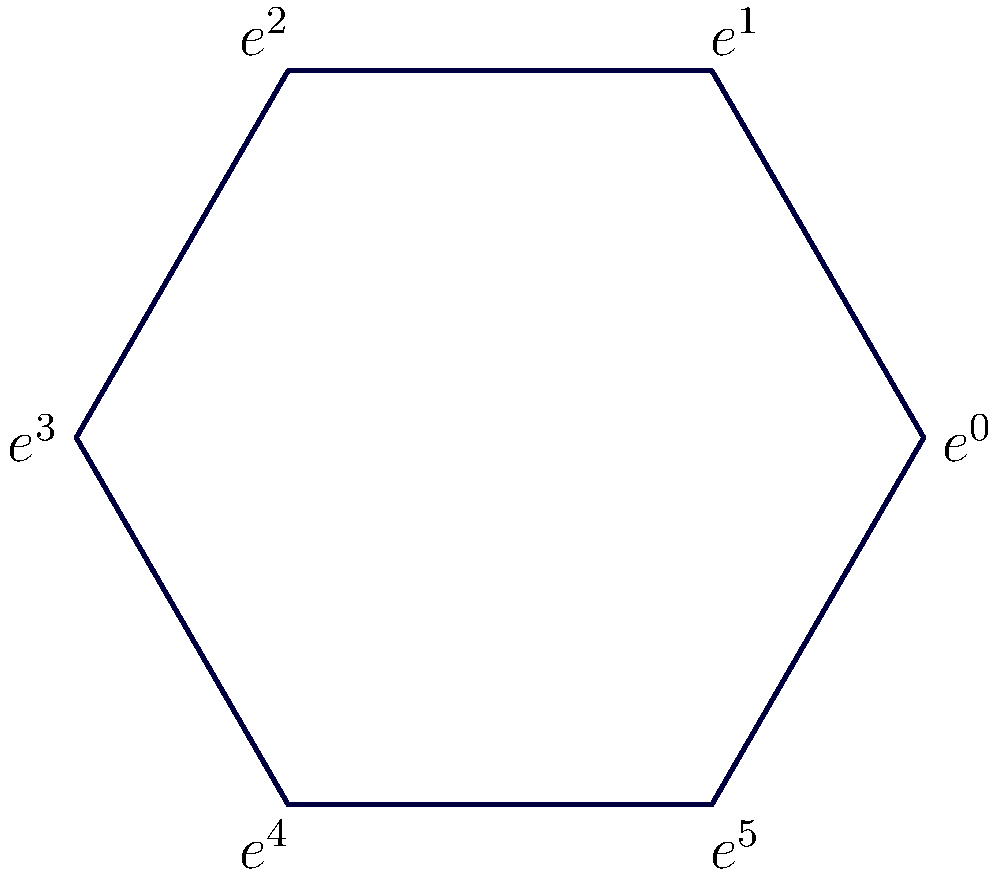Dans le contexte de la théorie des groupes, considérez le diagramme hexagonal représentant le groupe cyclique d'ordre 6. Si $r$ représente la rotation de 60° dans le sens horaire, quelle est l'expression de $r^4$ en termes des éléments du groupe ? Pour résoudre cette question, suivons ces étapes :

1) Dans un groupe cyclique d'ordre 6, nous avons les éléments $\{e^0, e^1, e^2, e^3, e^4, e^5\}$, où $e^0$ est l'identité.

2) La rotation $r$ correspond à une rotation de 60° dans le sens horaire, ce qui fait passer chaque élément à son successeur immédiat.

3) Appliquons $r$ quatre fois successivement :
   - $r(e^0) = e^1$
   - $r^2(e^0) = r(e^1) = e^2$
   - $r^3(e^0) = r(e^2) = e^3$
   - $r^4(e^0) = r(e^3) = e^4$

4) Nous constatons que $r^4$ fait passer de $e^0$ à $e^4$.

5) Dans la notation du groupe, cela signifie que $r^4 = e^4$.

Cette analyse montre comment la structure du groupe cyclique se manifeste géométriquement, illustrant le concept d'isomorphisme entre les représentations algébrique et géométrique du groupe.
Answer: $r^4 = e^4$ 